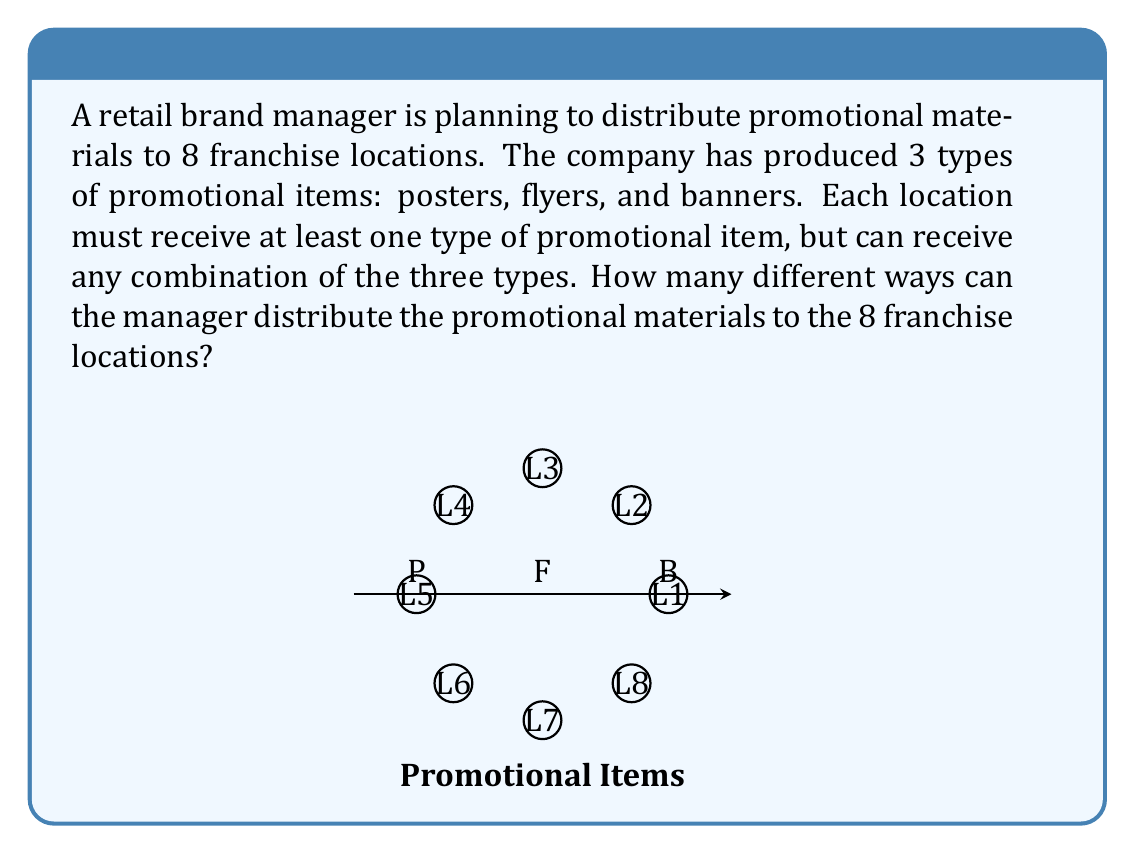Help me with this question. Let's approach this step-by-step:

1) First, we need to understand that this is a problem of distributing distinct objects (promotional materials) to distinct boxes (franchise locations).

2) For each location, we have 7 possible combinations of promotional materials:
   - Poster only (P)
   - Flyer only (F)
   - Banner only (B)
   - Poster and Flyer (PF)
   - Poster and Banner (PB)
   - Flyer and Banner (FB)
   - All three (PFB)

3) This means that for each location, we have 7 choices.

4) Since we have 8 locations, and each location's choice is independent of the others, we can use the multiplication principle.

5) The total number of ways to distribute the materials is thus:

   $$ 7 \times 7 \times 7 \times 7 \times 7 \times 7 \times 7 \times 7 = 7^8 $$

6) We can calculate this:
   $$ 7^8 = 5,764,801 $$

Therefore, there are 5,764,801 different ways to distribute the promotional materials to the 8 franchise locations.
Answer: $7^8 = 5,764,801$ 